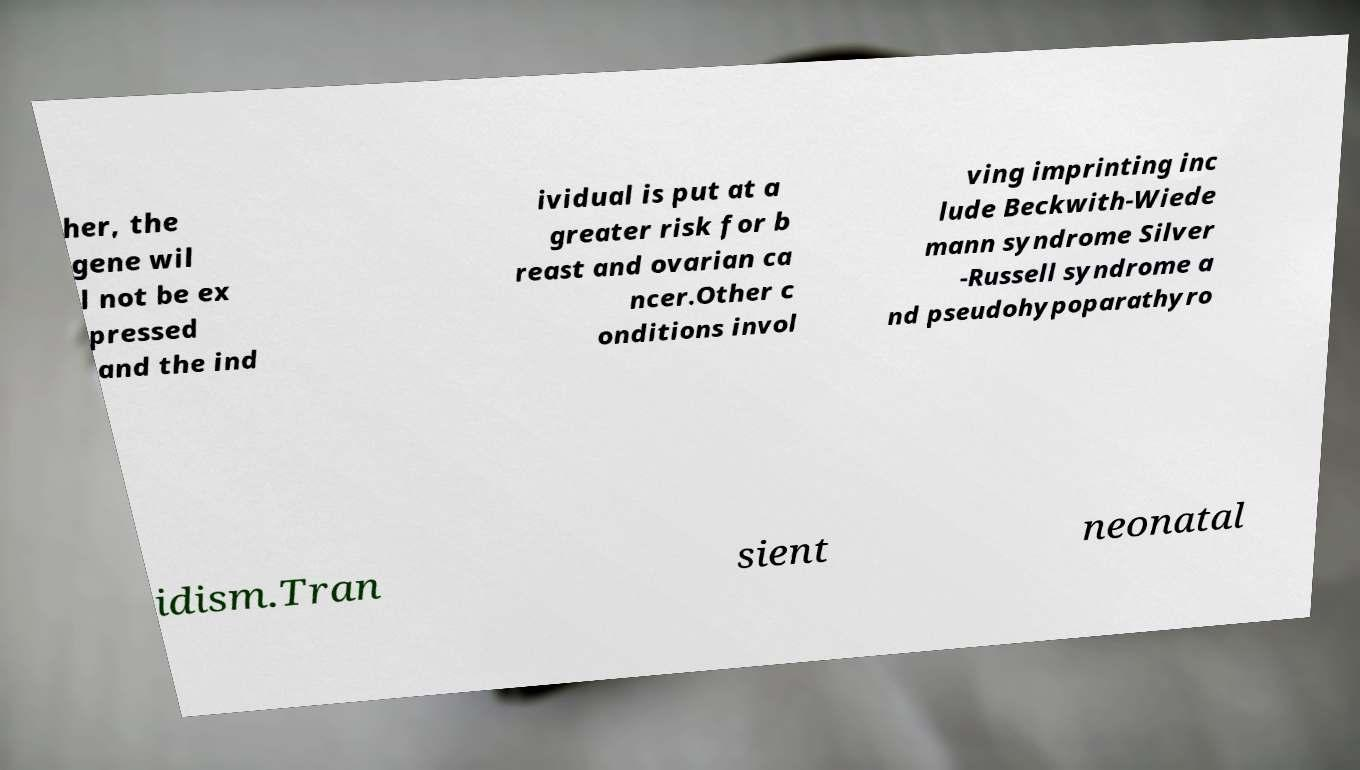What messages or text are displayed in this image? I need them in a readable, typed format. her, the gene wil l not be ex pressed and the ind ividual is put at a greater risk for b reast and ovarian ca ncer.Other c onditions invol ving imprinting inc lude Beckwith-Wiede mann syndrome Silver -Russell syndrome a nd pseudohypoparathyro idism.Tran sient neonatal 